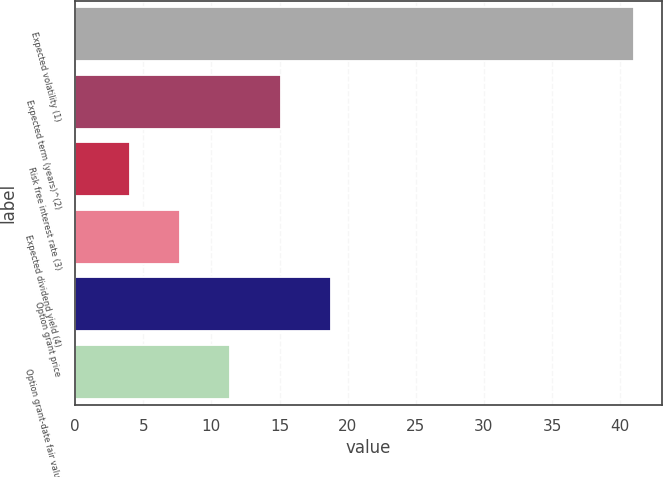Convert chart to OTSL. <chart><loc_0><loc_0><loc_500><loc_500><bar_chart><fcel>Expected volatility (1)<fcel>Expected term (years)^(2)<fcel>Risk free interest rate (3)<fcel>Expected dividend yield (4)<fcel>Option grant price<fcel>Option grant-date fair value<nl><fcel>41<fcel>15.1<fcel>4<fcel>7.7<fcel>18.8<fcel>11.4<nl></chart> 